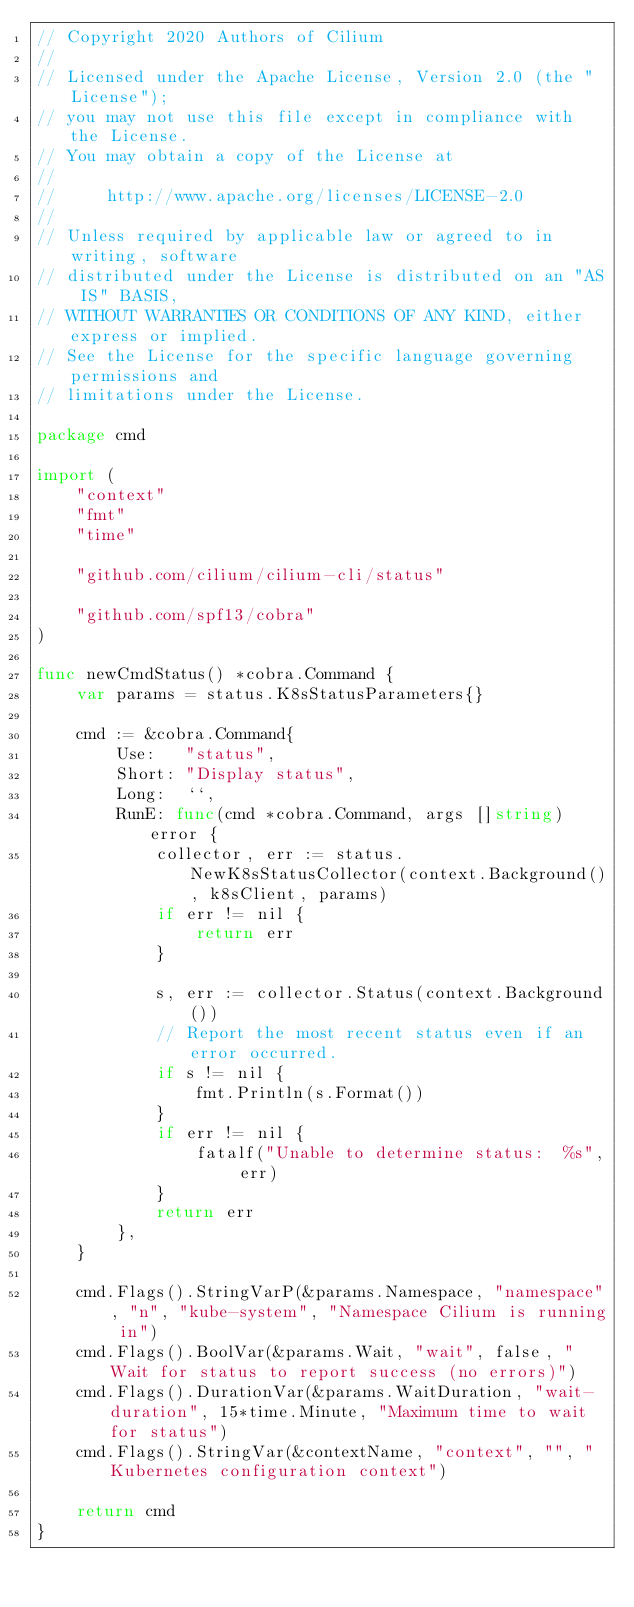<code> <loc_0><loc_0><loc_500><loc_500><_Go_>// Copyright 2020 Authors of Cilium
//
// Licensed under the Apache License, Version 2.0 (the "License");
// you may not use this file except in compliance with the License.
// You may obtain a copy of the License at
//
//     http://www.apache.org/licenses/LICENSE-2.0
//
// Unless required by applicable law or agreed to in writing, software
// distributed under the License is distributed on an "AS IS" BASIS,
// WITHOUT WARRANTIES OR CONDITIONS OF ANY KIND, either express or implied.
// See the License for the specific language governing permissions and
// limitations under the License.

package cmd

import (
	"context"
	"fmt"
	"time"

	"github.com/cilium/cilium-cli/status"

	"github.com/spf13/cobra"
)

func newCmdStatus() *cobra.Command {
	var params = status.K8sStatusParameters{}

	cmd := &cobra.Command{
		Use:   "status",
		Short: "Display status",
		Long:  ``,
		RunE: func(cmd *cobra.Command, args []string) error {
			collector, err := status.NewK8sStatusCollector(context.Background(), k8sClient, params)
			if err != nil {
				return err
			}

			s, err := collector.Status(context.Background())
			// Report the most recent status even if an error occurred.
			if s != nil {
				fmt.Println(s.Format())
			}
			if err != nil {
				fatalf("Unable to determine status:  %s", err)
			}
			return err
		},
	}

	cmd.Flags().StringVarP(&params.Namespace, "namespace", "n", "kube-system", "Namespace Cilium is running in")
	cmd.Flags().BoolVar(&params.Wait, "wait", false, "Wait for status to report success (no errors)")
	cmd.Flags().DurationVar(&params.WaitDuration, "wait-duration", 15*time.Minute, "Maximum time to wait for status")
	cmd.Flags().StringVar(&contextName, "context", "", "Kubernetes configuration context")

	return cmd
}
</code> 